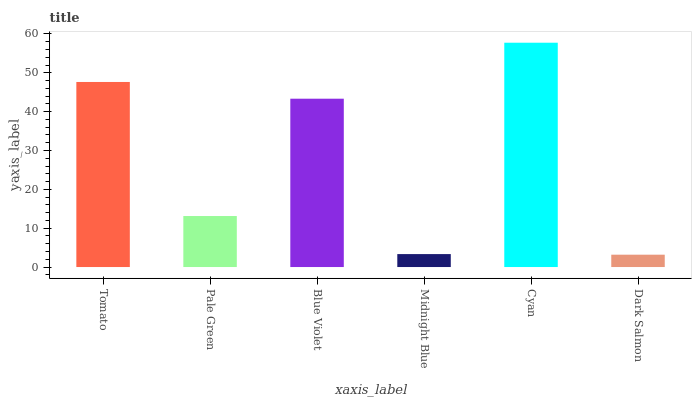Is Dark Salmon the minimum?
Answer yes or no. Yes. Is Cyan the maximum?
Answer yes or no. Yes. Is Pale Green the minimum?
Answer yes or no. No. Is Pale Green the maximum?
Answer yes or no. No. Is Tomato greater than Pale Green?
Answer yes or no. Yes. Is Pale Green less than Tomato?
Answer yes or no. Yes. Is Pale Green greater than Tomato?
Answer yes or no. No. Is Tomato less than Pale Green?
Answer yes or no. No. Is Blue Violet the high median?
Answer yes or no. Yes. Is Pale Green the low median?
Answer yes or no. Yes. Is Cyan the high median?
Answer yes or no. No. Is Cyan the low median?
Answer yes or no. No. 